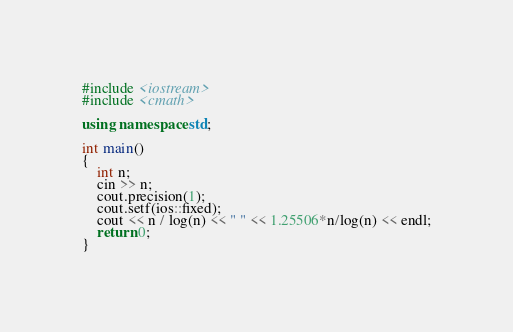Convert code to text. <code><loc_0><loc_0><loc_500><loc_500><_C++_>#include <iostream>
#include <cmath>

using namespace std;

int main()
{
    int n;
    cin >> n;
    cout.precision(1);
    cout.setf(ios::fixed);
    cout << n / log(n) << " " << 1.25506*n/log(n) << endl;
    return 0;
}
</code> 